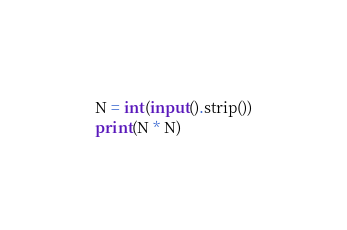<code> <loc_0><loc_0><loc_500><loc_500><_Python_>N = int(input().strip())
print(N * N)</code> 